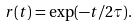<formula> <loc_0><loc_0><loc_500><loc_500>r ( t ) = \exp ( - t / 2 \tau ) .</formula> 